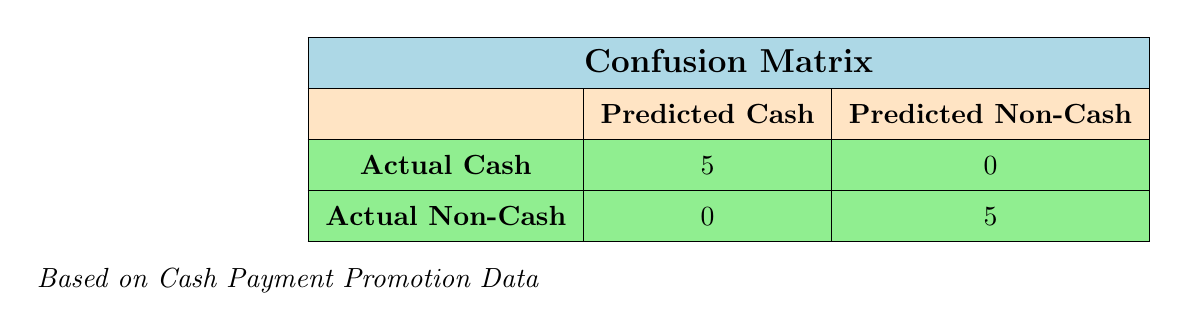What is the total number of actual cash payments that were successful? From the confusion matrix, the row for "Actual Cash" indicates there were 5 successful predictions of cash payments.
Answer: 5 How many customers did not purchase with cash, and were predicted as non-cash? Looking at the "Actual Non-Cash" row, the value in the "Predicted Non-Cash" column is 5, indicating that all non-cash customers were correctly predicted.
Answer: 5 Did any customer who purchased with cash get predicted as non-cash? In the table, under "Actual Cash," the number of predicted non-cash is 0, showing that no cash customers were incorrectly predicted.
Answer: No What is the accuracy of the predictions made on cash payments? The total predictions made are the sum of both rows, which is 10 (5 actual cash + 5 actual non-cash). The number of correct predictions is also 10 (5 cash and 5 non-cash). Thus, accuracy is calculated as correct predictions (10) divided by total predictions (10), giving an accuracy of 100%.
Answer: 100% How many cash customers could have been predicted incorrectly? In the confusion matrix, the "Actual Cash" row shows that 0 customers were predicted incorrectly as non-cash, which means no cash customer was incorrectly predicted.
Answer: 0 What is the total number of predictions for customers who paid in cash? Referring to the "Actual Cash" row of the matrix, the total for this category, which counts only successful predictions, is 5 and no failures, hence the total is 5.
Answer: 5 In the scenario of offering cash payment promotions, did all cash purchases succeed according to the matrix? Yes, the "Actual Cash" row shows 5 successful predictions with 0 failures, indicating all cash purchases succeeded.
Answer: Yes What percentage of actual cash purchases were successful? All actual cash purchases were successful, totaling 5. To find the percentage, the formula is (successes / total cash purchases) * 100, which is (5 / 5) * 100 = 100%.
Answer: 100% 